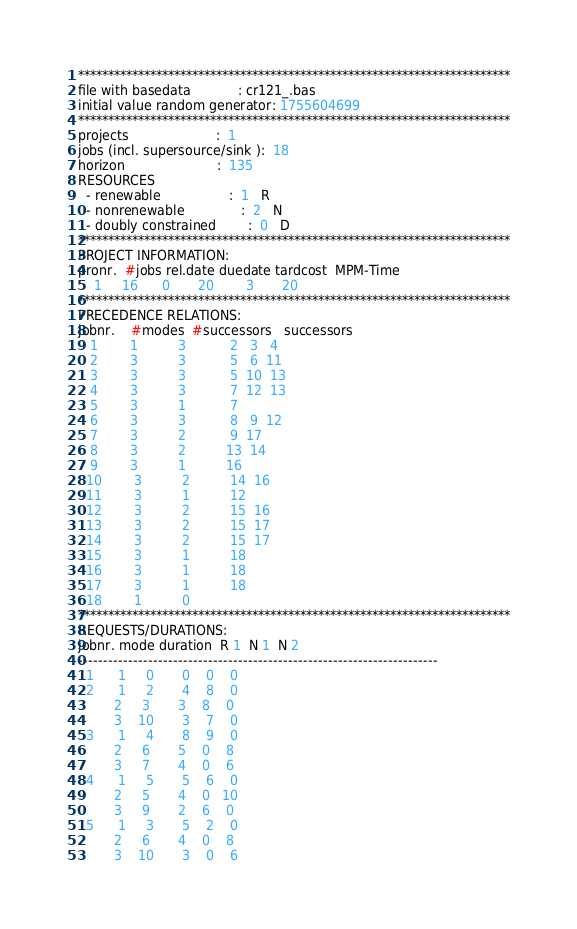Convert code to text. <code><loc_0><loc_0><loc_500><loc_500><_ObjectiveC_>************************************************************************
file with basedata            : cr121_.bas
initial value random generator: 1755604699
************************************************************************
projects                      :  1
jobs (incl. supersource/sink ):  18
horizon                       :  135
RESOURCES
  - renewable                 :  1   R
  - nonrenewable              :  2   N
  - doubly constrained        :  0   D
************************************************************************
PROJECT INFORMATION:
pronr.  #jobs rel.date duedate tardcost  MPM-Time
    1     16      0       20        3       20
************************************************************************
PRECEDENCE RELATIONS:
jobnr.    #modes  #successors   successors
   1        1          3           2   3   4
   2        3          3           5   6  11
   3        3          3           5  10  13
   4        3          3           7  12  13
   5        3          1           7
   6        3          3           8   9  12
   7        3          2           9  17
   8        3          2          13  14
   9        3          1          16
  10        3          2          14  16
  11        3          1          12
  12        3          2          15  16
  13        3          2          15  17
  14        3          2          15  17
  15        3          1          18
  16        3          1          18
  17        3          1          18
  18        1          0        
************************************************************************
REQUESTS/DURATIONS:
jobnr. mode duration  R 1  N 1  N 2
------------------------------------------------------------------------
  1      1     0       0    0    0
  2      1     2       4    8    0
         2     3       3    8    0
         3    10       3    7    0
  3      1     4       8    9    0
         2     6       5    0    8
         3     7       4    0    6
  4      1     5       5    6    0
         2     5       4    0   10
         3     9       2    6    0
  5      1     3       5    2    0
         2     6       4    0    8
         3    10       3    0    6</code> 